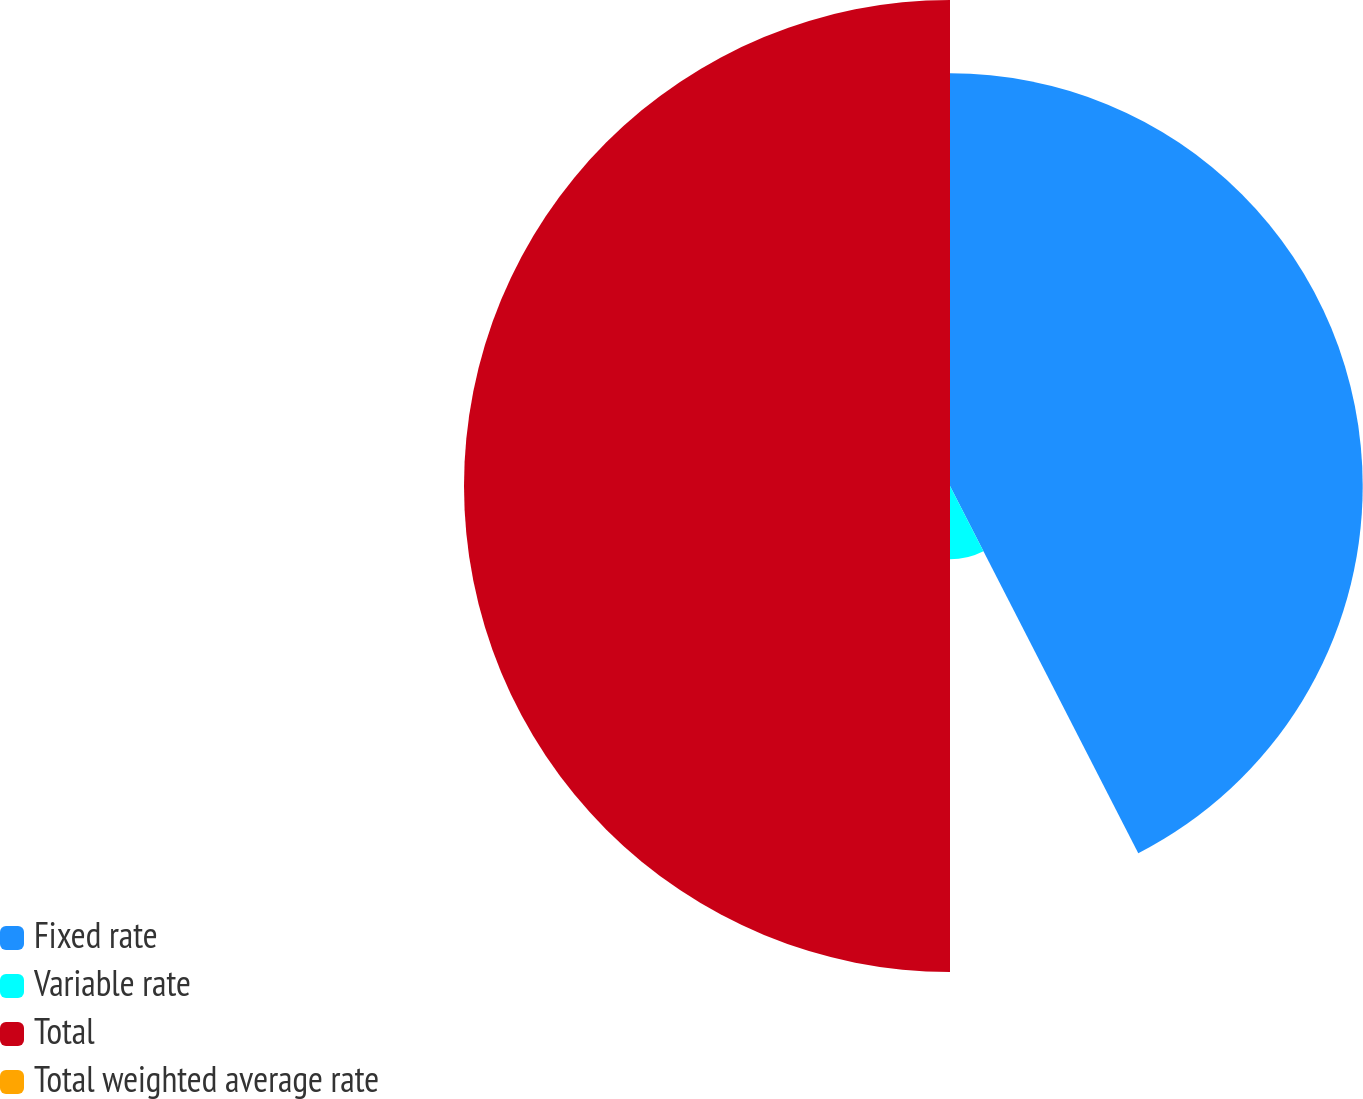Convert chart to OTSL. <chart><loc_0><loc_0><loc_500><loc_500><pie_chart><fcel>Fixed rate<fcel>Variable rate<fcel>Total<fcel>Total weighted average rate<nl><fcel>42.46%<fcel>7.54%<fcel>50.0%<fcel>0.0%<nl></chart> 